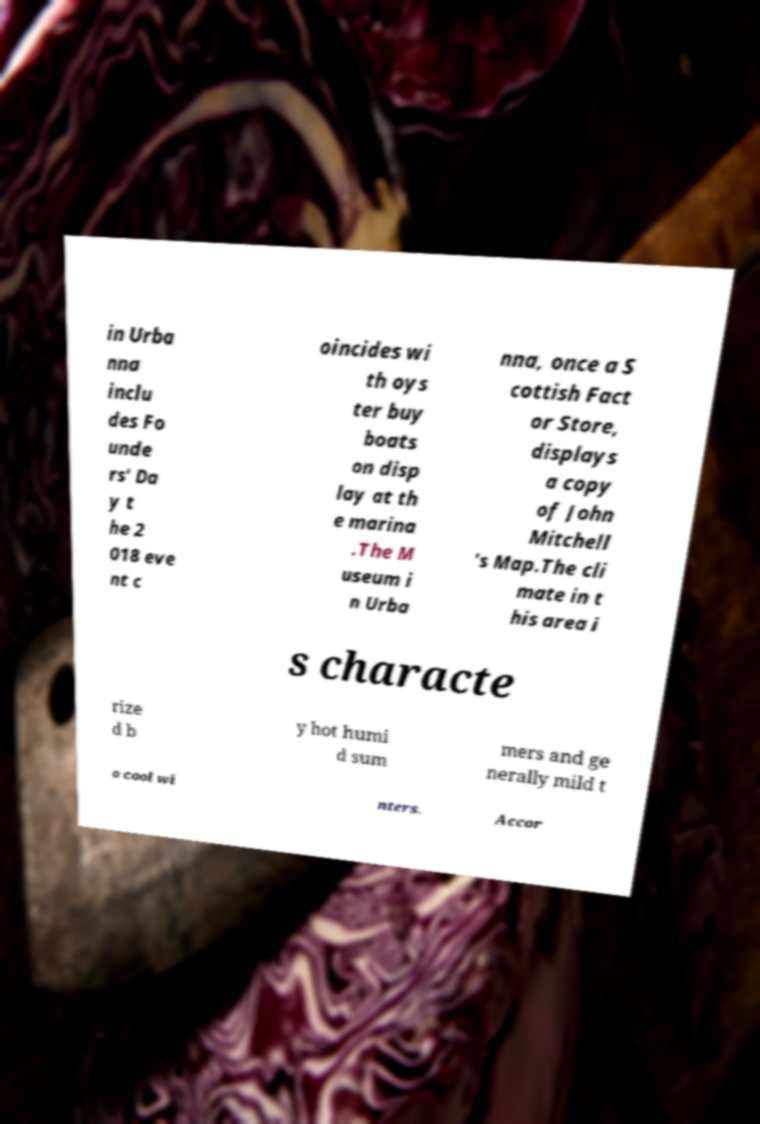Can you read and provide the text displayed in the image?This photo seems to have some interesting text. Can you extract and type it out for me? in Urba nna inclu des Fo unde rs' Da y t he 2 018 eve nt c oincides wi th oys ter buy boats on disp lay at th e marina .The M useum i n Urba nna, once a S cottish Fact or Store, displays a copy of John Mitchell 's Map.The cli mate in t his area i s characte rize d b y hot humi d sum mers and ge nerally mild t o cool wi nters. Accor 